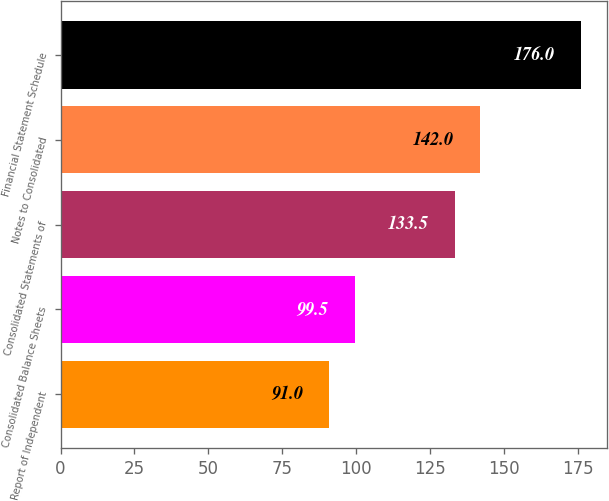Convert chart to OTSL. <chart><loc_0><loc_0><loc_500><loc_500><bar_chart><fcel>Report of Independent<fcel>Consolidated Balance Sheets<fcel>Consolidated Statements of<fcel>Notes to Consolidated<fcel>Financial Statement Schedule<nl><fcel>91<fcel>99.5<fcel>133.5<fcel>142<fcel>176<nl></chart> 